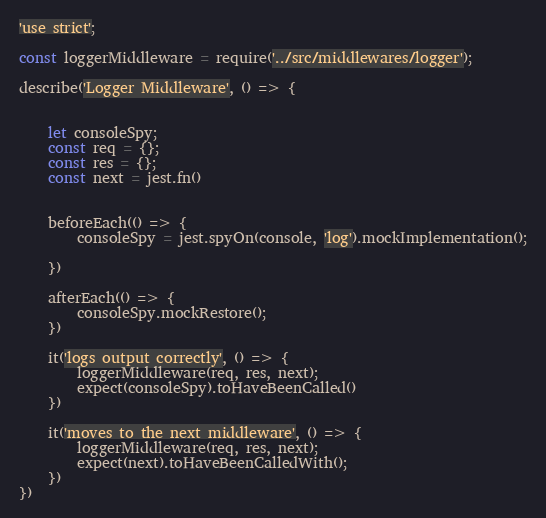Convert code to text. <code><loc_0><loc_0><loc_500><loc_500><_JavaScript_>'use strict';

const loggerMiddleware = require('../src/middlewares/logger');

describe('Logger Middleware', () => {


    let consoleSpy;
    const req = {};
    const res = {};
    const next = jest.fn()


    beforeEach(() => {
        consoleSpy = jest.spyOn(console, 'log').mockImplementation();

    })

    afterEach(() => {
        consoleSpy.mockRestore();
    })

    it('logs output correctly', () => {
        loggerMiddleware(req, res, next);
        expect(consoleSpy).toHaveBeenCalled()
    })

    it('moves to the next middleware', () => {
        loggerMiddleware(req, res, next);
        expect(next).toHaveBeenCalledWith();
    })
})</code> 